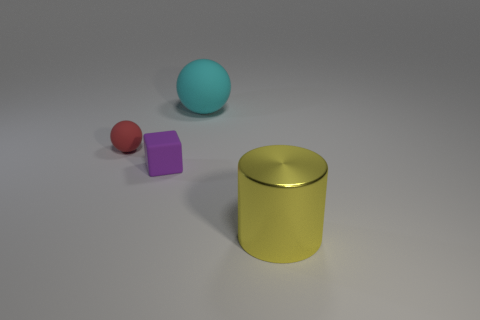Subtract all cylinders. How many objects are left? 3 Add 1 big blue matte objects. How many objects exist? 5 Subtract all cyan cubes. How many gray cylinders are left? 0 Subtract all big spheres. Subtract all red rubber objects. How many objects are left? 2 Add 1 cylinders. How many cylinders are left? 2 Add 2 yellow things. How many yellow things exist? 3 Subtract all cyan spheres. How many spheres are left? 1 Subtract 0 green cylinders. How many objects are left? 4 Subtract 1 blocks. How many blocks are left? 0 Subtract all cyan spheres. Subtract all gray blocks. How many spheres are left? 1 